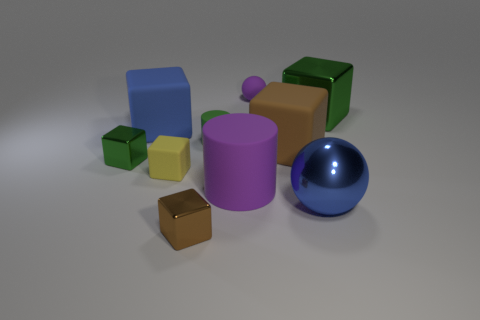There is a large purple cylinder; are there any purple objects right of it? Based on the image, to the right of the large purple cylinder, there is no other purple object. All objects situated to the right of the cylinder exhibit different colors. 